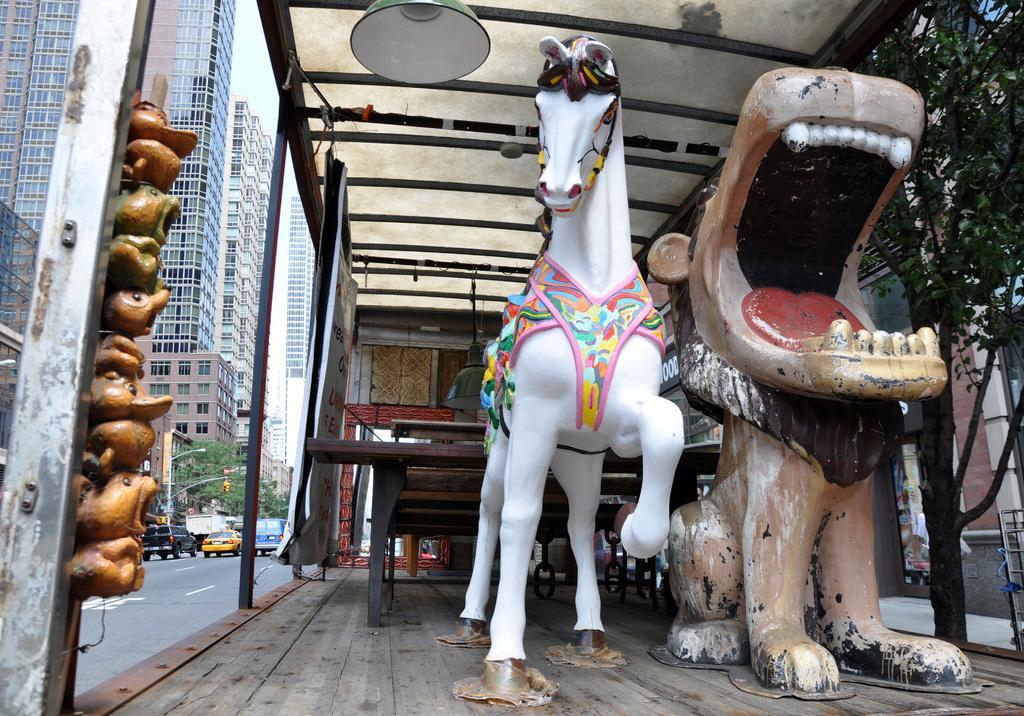Can you describe this image briefly? In this image we can see statues placed on the wooden surface. Behind the statues we can see electric lights hanging from the rods and some decors attached to the rod. In the background we can see buildings, street poles, street lights and motor vehicles on the road. 